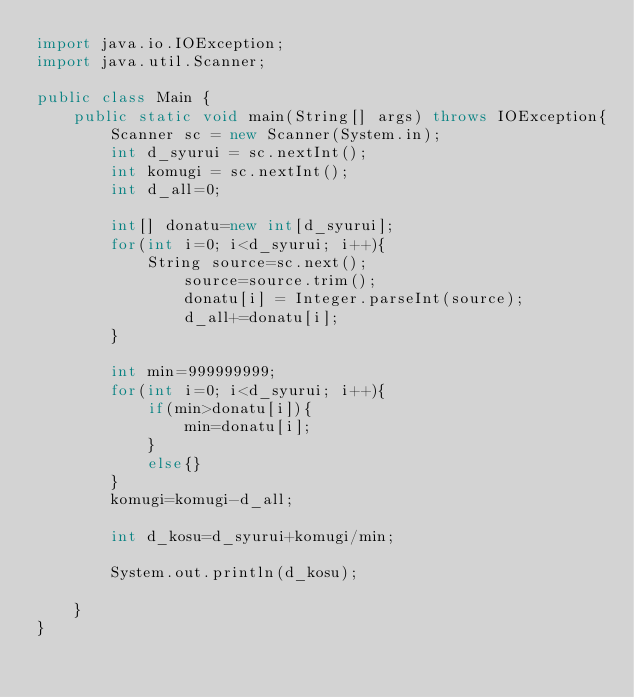<code> <loc_0><loc_0><loc_500><loc_500><_Java_>import java.io.IOException;
import java.util.Scanner;

public class Main {
	public static void main(String[] args) throws IOException{
		Scanner sc = new Scanner(System.in);
		int d_syurui = sc.nextInt();
		int komugi = sc.nextInt();
		int d_all=0;

		int[] donatu=new int[d_syurui];
		for(int i=0; i<d_syurui; i++){
			String source=sc.next();
				source=source.trim();
				donatu[i] = Integer.parseInt(source);
				d_all+=donatu[i];
		}

		int min=999999999;
		for(int i=0; i<d_syurui; i++){
			if(min>donatu[i]){
				min=donatu[i];
			}
			else{}
		}
		komugi=komugi-d_all;

		int d_kosu=d_syurui+komugi/min;

		System.out.println(d_kosu);

	}
}
</code> 